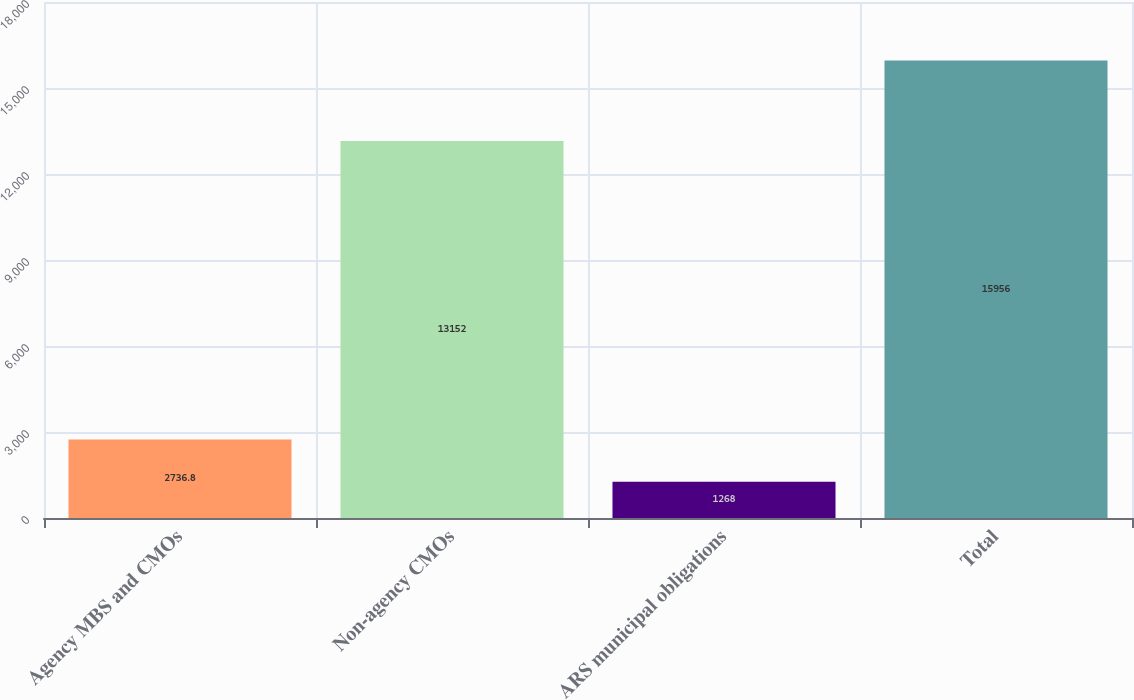Convert chart. <chart><loc_0><loc_0><loc_500><loc_500><bar_chart><fcel>Agency MBS and CMOs<fcel>Non-agency CMOs<fcel>ARS municipal obligations<fcel>Total<nl><fcel>2736.8<fcel>13152<fcel>1268<fcel>15956<nl></chart> 